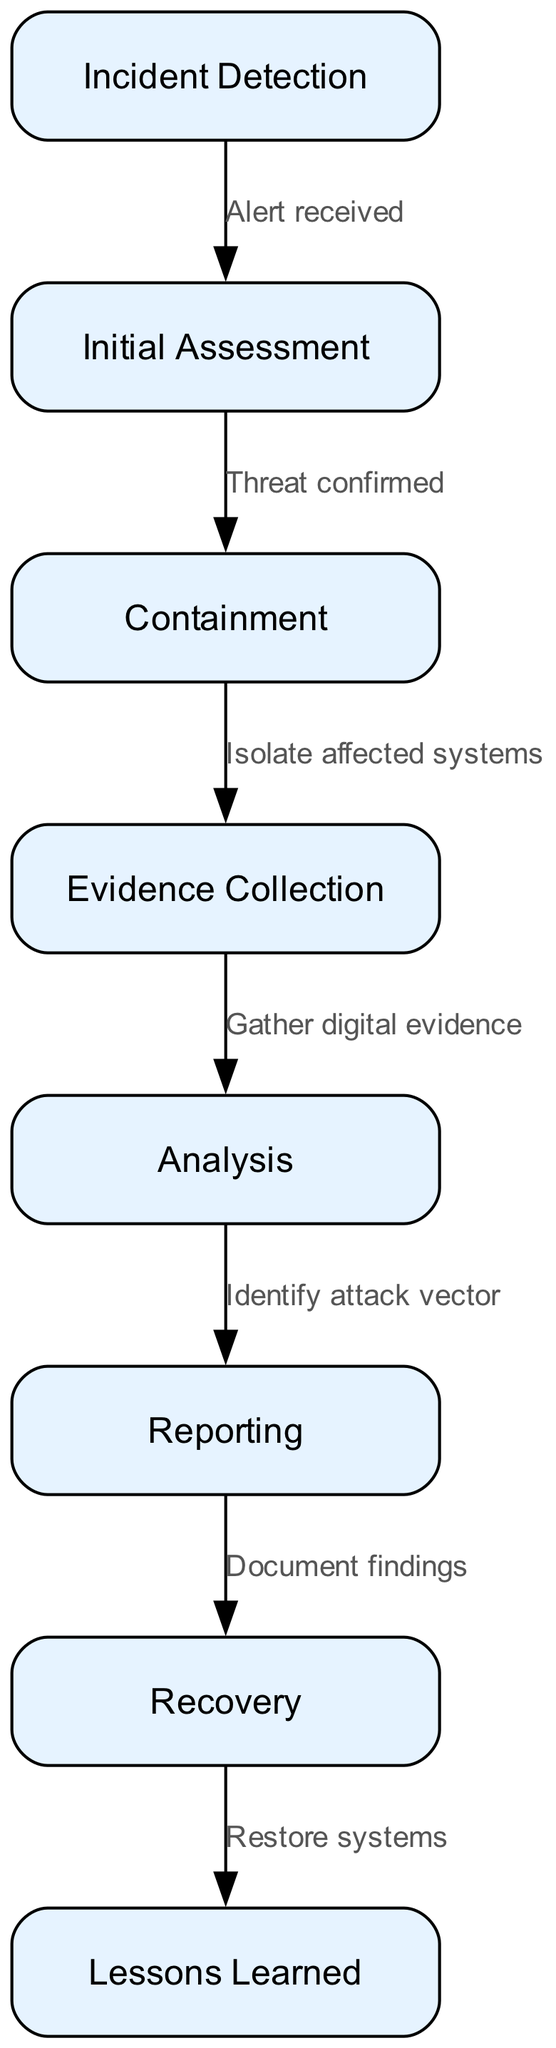What is the first step of the incident response procedure? The first step mentioned in the diagram is "Incident Detection." This node is positioned at the top of the flowchart, indicating it is the starting point for further actions to follow after an incident is detected.
Answer: Incident Detection How many nodes are present in this flowchart? The flowchart includes a total of 8 nodes, each representing a different step in the incident response process. This count is derived from the data provided, listing all unique steps in the response.
Answer: 8 What action follows after the "Initial Assessment"? According to the flowchart, the action that follows "Initial Assessment" is "Containment." This transition is indicated by the edge connecting these two nodes, showing the process flow in incident response.
Answer: Containment What is the final step in the incident response process? The last step outlined in the flowchart is "Lessons Learned." This node comes after the "Recovery" process, signifying it is the concluding stage where evaluations are likely made after the incident has been managed.
Answer: Lessons Learned What must be done before "Recovery" can occur? Prior to "Recovery," the flowchart states that "Reporting" must be completed. This is important as it involves documenting findings and potentially submitting reports that inform the recovery actions to restore affected systems.
Answer: Reporting What action is taken after "Evidence Collection"? Once "Evidence Collection" is completed, the next action is "Analysis." This step is vital for understanding the gathered evidence and determining the nature of the incident based on the collected data.
Answer: Analysis Which node represents the action of isolating affected systems? The action of isolating affected systems is represented by the node labeled "Containment." This is a critical step to prevent the spread of the cyber threat following initial assessments.
Answer: Containment What connects "Analysis" to "Reporting"? The edge labeled "Identify attack vector" connects "Analysis" to "Reporting." This indicates that findings from the analysis help shape the reporting process and document what was learned from the incident.
Answer: Identify attack vector 